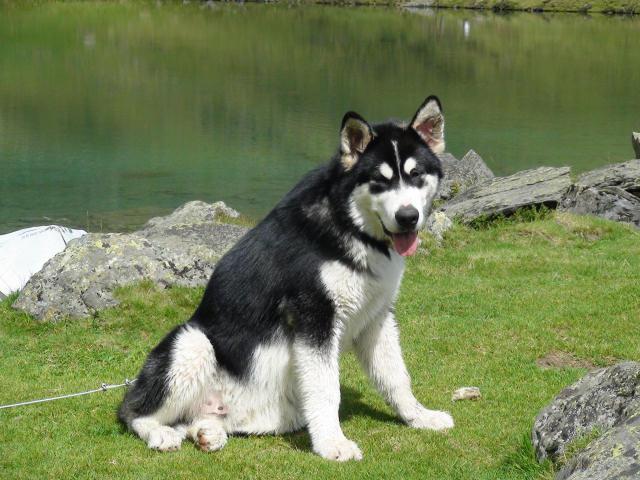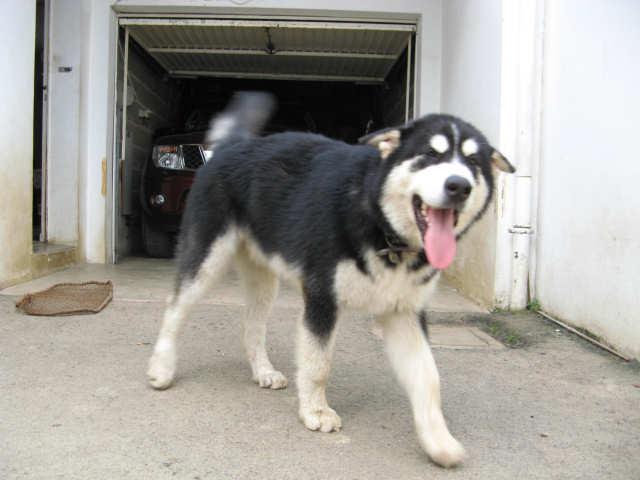The first image is the image on the left, the second image is the image on the right. Examine the images to the left and right. Is the description "Each image contains one dog, each dog has its tongue hanging down, one dog is sitting upright, and one dog is standing." accurate? Answer yes or no. Yes. The first image is the image on the left, the second image is the image on the right. Analyze the images presented: Is the assertion "Both dogs have their tongues hanging out." valid? Answer yes or no. Yes. 